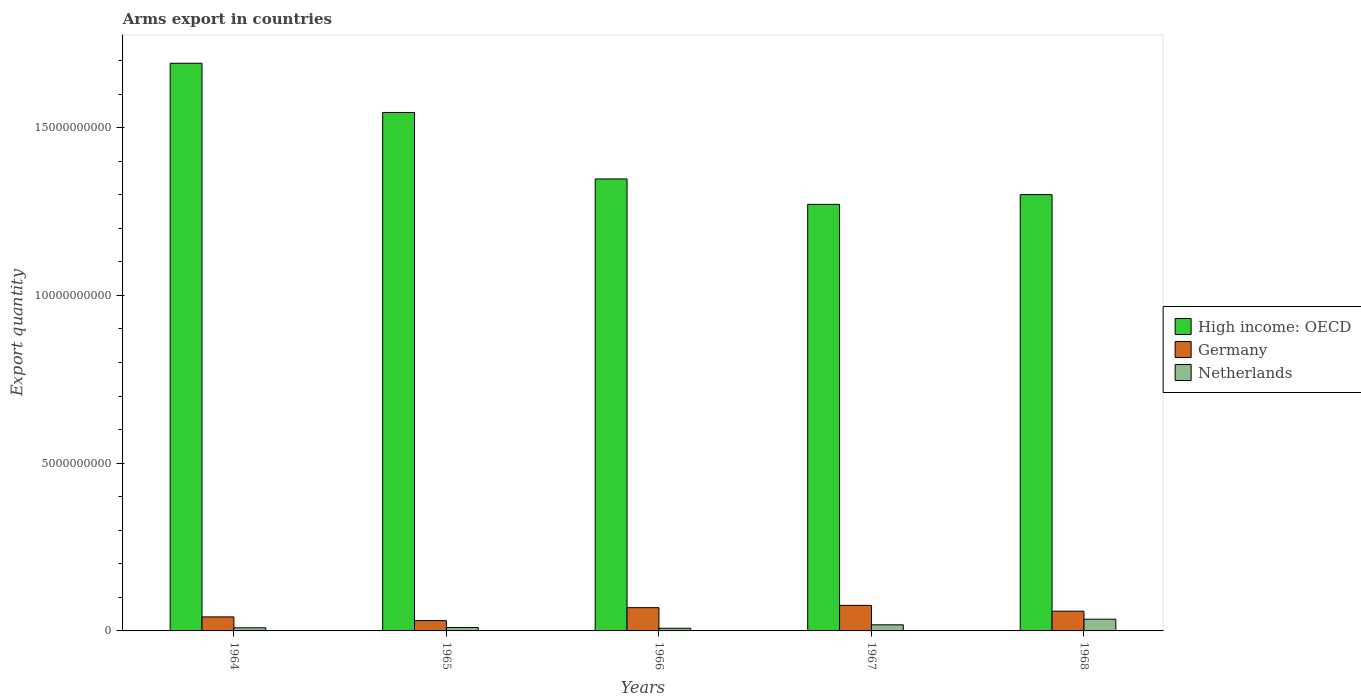What is the label of the 1st group of bars from the left?
Your response must be concise. 1964. What is the total arms export in Netherlands in 1968?
Offer a terse response. 3.50e+08. Across all years, what is the maximum total arms export in Netherlands?
Your answer should be very brief. 3.50e+08. Across all years, what is the minimum total arms export in Netherlands?
Your answer should be very brief. 7.90e+07. In which year was the total arms export in Germany maximum?
Your response must be concise. 1967. In which year was the total arms export in Netherlands minimum?
Offer a terse response. 1966. What is the total total arms export in High income: OECD in the graph?
Provide a short and direct response. 7.16e+1. What is the difference between the total arms export in High income: OECD in 1966 and that in 1968?
Give a very brief answer. 4.67e+08. What is the difference between the total arms export in Netherlands in 1965 and the total arms export in Germany in 1966?
Offer a terse response. -5.93e+08. What is the average total arms export in Netherlands per year?
Your response must be concise. 1.61e+08. In the year 1967, what is the difference between the total arms export in Netherlands and total arms export in Germany?
Your answer should be very brief. -5.79e+08. In how many years, is the total arms export in Netherlands greater than 10000000000?
Give a very brief answer. 0. What is the ratio of the total arms export in High income: OECD in 1965 to that in 1967?
Offer a terse response. 1.22. What is the difference between the highest and the second highest total arms export in Germany?
Offer a very short reply. 6.80e+07. What is the difference between the highest and the lowest total arms export in High income: OECD?
Provide a short and direct response. 4.20e+09. What does the 1st bar from the left in 1965 represents?
Give a very brief answer. High income: OECD. How many bars are there?
Offer a terse response. 15. How many years are there in the graph?
Your answer should be very brief. 5. What is the difference between two consecutive major ticks on the Y-axis?
Provide a succinct answer. 5.00e+09. How many legend labels are there?
Provide a short and direct response. 3. What is the title of the graph?
Give a very brief answer. Arms export in countries. What is the label or title of the Y-axis?
Provide a short and direct response. Export quantity. What is the Export quantity in High income: OECD in 1964?
Keep it short and to the point. 1.69e+1. What is the Export quantity of Germany in 1964?
Keep it short and to the point. 4.18e+08. What is the Export quantity in Netherlands in 1964?
Your response must be concise. 9.30e+07. What is the Export quantity of High income: OECD in 1965?
Give a very brief answer. 1.55e+1. What is the Export quantity of Germany in 1965?
Offer a terse response. 3.07e+08. What is the Export quantity in High income: OECD in 1966?
Ensure brevity in your answer.  1.35e+1. What is the Export quantity of Germany in 1966?
Ensure brevity in your answer.  6.93e+08. What is the Export quantity of Netherlands in 1966?
Offer a very short reply. 7.90e+07. What is the Export quantity in High income: OECD in 1967?
Give a very brief answer. 1.27e+1. What is the Export quantity of Germany in 1967?
Offer a very short reply. 7.61e+08. What is the Export quantity in Netherlands in 1967?
Offer a very short reply. 1.82e+08. What is the Export quantity in High income: OECD in 1968?
Keep it short and to the point. 1.30e+1. What is the Export quantity of Germany in 1968?
Provide a short and direct response. 5.88e+08. What is the Export quantity of Netherlands in 1968?
Make the answer very short. 3.50e+08. Across all years, what is the maximum Export quantity in High income: OECD?
Your answer should be compact. 1.69e+1. Across all years, what is the maximum Export quantity in Germany?
Give a very brief answer. 7.61e+08. Across all years, what is the maximum Export quantity of Netherlands?
Offer a very short reply. 3.50e+08. Across all years, what is the minimum Export quantity of High income: OECD?
Keep it short and to the point. 1.27e+1. Across all years, what is the minimum Export quantity of Germany?
Make the answer very short. 3.07e+08. Across all years, what is the minimum Export quantity of Netherlands?
Provide a short and direct response. 7.90e+07. What is the total Export quantity of High income: OECD in the graph?
Provide a short and direct response. 7.16e+1. What is the total Export quantity of Germany in the graph?
Keep it short and to the point. 2.77e+09. What is the total Export quantity of Netherlands in the graph?
Your answer should be compact. 8.04e+08. What is the difference between the Export quantity of High income: OECD in 1964 and that in 1965?
Your answer should be very brief. 1.47e+09. What is the difference between the Export quantity of Germany in 1964 and that in 1965?
Ensure brevity in your answer.  1.11e+08. What is the difference between the Export quantity of Netherlands in 1964 and that in 1965?
Ensure brevity in your answer.  -7.00e+06. What is the difference between the Export quantity of High income: OECD in 1964 and that in 1966?
Keep it short and to the point. 3.45e+09. What is the difference between the Export quantity in Germany in 1964 and that in 1966?
Keep it short and to the point. -2.75e+08. What is the difference between the Export quantity in Netherlands in 1964 and that in 1966?
Give a very brief answer. 1.40e+07. What is the difference between the Export quantity of High income: OECD in 1964 and that in 1967?
Your answer should be very brief. 4.20e+09. What is the difference between the Export quantity in Germany in 1964 and that in 1967?
Make the answer very short. -3.43e+08. What is the difference between the Export quantity of Netherlands in 1964 and that in 1967?
Ensure brevity in your answer.  -8.90e+07. What is the difference between the Export quantity in High income: OECD in 1964 and that in 1968?
Give a very brief answer. 3.92e+09. What is the difference between the Export quantity in Germany in 1964 and that in 1968?
Your response must be concise. -1.70e+08. What is the difference between the Export quantity of Netherlands in 1964 and that in 1968?
Your answer should be very brief. -2.57e+08. What is the difference between the Export quantity of High income: OECD in 1965 and that in 1966?
Make the answer very short. 1.98e+09. What is the difference between the Export quantity of Germany in 1965 and that in 1966?
Provide a succinct answer. -3.86e+08. What is the difference between the Export quantity of Netherlands in 1965 and that in 1966?
Your answer should be very brief. 2.10e+07. What is the difference between the Export quantity in High income: OECD in 1965 and that in 1967?
Give a very brief answer. 2.74e+09. What is the difference between the Export quantity of Germany in 1965 and that in 1967?
Keep it short and to the point. -4.54e+08. What is the difference between the Export quantity of Netherlands in 1965 and that in 1967?
Your response must be concise. -8.20e+07. What is the difference between the Export quantity in High income: OECD in 1965 and that in 1968?
Your answer should be compact. 2.45e+09. What is the difference between the Export quantity of Germany in 1965 and that in 1968?
Make the answer very short. -2.81e+08. What is the difference between the Export quantity of Netherlands in 1965 and that in 1968?
Provide a succinct answer. -2.50e+08. What is the difference between the Export quantity in High income: OECD in 1966 and that in 1967?
Offer a terse response. 7.57e+08. What is the difference between the Export quantity of Germany in 1966 and that in 1967?
Provide a short and direct response. -6.80e+07. What is the difference between the Export quantity in Netherlands in 1966 and that in 1967?
Make the answer very short. -1.03e+08. What is the difference between the Export quantity in High income: OECD in 1966 and that in 1968?
Offer a terse response. 4.67e+08. What is the difference between the Export quantity in Germany in 1966 and that in 1968?
Provide a short and direct response. 1.05e+08. What is the difference between the Export quantity in Netherlands in 1966 and that in 1968?
Keep it short and to the point. -2.71e+08. What is the difference between the Export quantity in High income: OECD in 1967 and that in 1968?
Your answer should be very brief. -2.90e+08. What is the difference between the Export quantity in Germany in 1967 and that in 1968?
Provide a short and direct response. 1.73e+08. What is the difference between the Export quantity in Netherlands in 1967 and that in 1968?
Make the answer very short. -1.68e+08. What is the difference between the Export quantity in High income: OECD in 1964 and the Export quantity in Germany in 1965?
Offer a very short reply. 1.66e+1. What is the difference between the Export quantity in High income: OECD in 1964 and the Export quantity in Netherlands in 1965?
Your answer should be very brief. 1.68e+1. What is the difference between the Export quantity in Germany in 1964 and the Export quantity in Netherlands in 1965?
Offer a very short reply. 3.18e+08. What is the difference between the Export quantity in High income: OECD in 1964 and the Export quantity in Germany in 1966?
Your answer should be very brief. 1.62e+1. What is the difference between the Export quantity in High income: OECD in 1964 and the Export quantity in Netherlands in 1966?
Provide a short and direct response. 1.68e+1. What is the difference between the Export quantity of Germany in 1964 and the Export quantity of Netherlands in 1966?
Ensure brevity in your answer.  3.39e+08. What is the difference between the Export quantity of High income: OECD in 1964 and the Export quantity of Germany in 1967?
Your answer should be compact. 1.62e+1. What is the difference between the Export quantity of High income: OECD in 1964 and the Export quantity of Netherlands in 1967?
Your answer should be very brief. 1.67e+1. What is the difference between the Export quantity in Germany in 1964 and the Export quantity in Netherlands in 1967?
Your answer should be very brief. 2.36e+08. What is the difference between the Export quantity in High income: OECD in 1964 and the Export quantity in Germany in 1968?
Make the answer very short. 1.63e+1. What is the difference between the Export quantity of High income: OECD in 1964 and the Export quantity of Netherlands in 1968?
Make the answer very short. 1.66e+1. What is the difference between the Export quantity of Germany in 1964 and the Export quantity of Netherlands in 1968?
Ensure brevity in your answer.  6.80e+07. What is the difference between the Export quantity in High income: OECD in 1965 and the Export quantity in Germany in 1966?
Your answer should be very brief. 1.48e+1. What is the difference between the Export quantity of High income: OECD in 1965 and the Export quantity of Netherlands in 1966?
Make the answer very short. 1.54e+1. What is the difference between the Export quantity in Germany in 1965 and the Export quantity in Netherlands in 1966?
Your response must be concise. 2.28e+08. What is the difference between the Export quantity of High income: OECD in 1965 and the Export quantity of Germany in 1967?
Provide a short and direct response. 1.47e+1. What is the difference between the Export quantity in High income: OECD in 1965 and the Export quantity in Netherlands in 1967?
Give a very brief answer. 1.53e+1. What is the difference between the Export quantity of Germany in 1965 and the Export quantity of Netherlands in 1967?
Ensure brevity in your answer.  1.25e+08. What is the difference between the Export quantity of High income: OECD in 1965 and the Export quantity of Germany in 1968?
Offer a terse response. 1.49e+1. What is the difference between the Export quantity of High income: OECD in 1965 and the Export quantity of Netherlands in 1968?
Your answer should be very brief. 1.51e+1. What is the difference between the Export quantity in Germany in 1965 and the Export quantity in Netherlands in 1968?
Your answer should be very brief. -4.30e+07. What is the difference between the Export quantity of High income: OECD in 1966 and the Export quantity of Germany in 1967?
Keep it short and to the point. 1.27e+1. What is the difference between the Export quantity of High income: OECD in 1966 and the Export quantity of Netherlands in 1967?
Your response must be concise. 1.33e+1. What is the difference between the Export quantity of Germany in 1966 and the Export quantity of Netherlands in 1967?
Your answer should be very brief. 5.11e+08. What is the difference between the Export quantity in High income: OECD in 1966 and the Export quantity in Germany in 1968?
Keep it short and to the point. 1.29e+1. What is the difference between the Export quantity in High income: OECD in 1966 and the Export quantity in Netherlands in 1968?
Provide a short and direct response. 1.31e+1. What is the difference between the Export quantity in Germany in 1966 and the Export quantity in Netherlands in 1968?
Provide a succinct answer. 3.43e+08. What is the difference between the Export quantity in High income: OECD in 1967 and the Export quantity in Germany in 1968?
Offer a very short reply. 1.21e+1. What is the difference between the Export quantity of High income: OECD in 1967 and the Export quantity of Netherlands in 1968?
Provide a succinct answer. 1.24e+1. What is the difference between the Export quantity of Germany in 1967 and the Export quantity of Netherlands in 1968?
Provide a short and direct response. 4.11e+08. What is the average Export quantity of High income: OECD per year?
Your answer should be compact. 1.43e+1. What is the average Export quantity of Germany per year?
Make the answer very short. 5.53e+08. What is the average Export quantity of Netherlands per year?
Provide a succinct answer. 1.61e+08. In the year 1964, what is the difference between the Export quantity of High income: OECD and Export quantity of Germany?
Your answer should be compact. 1.65e+1. In the year 1964, what is the difference between the Export quantity in High income: OECD and Export quantity in Netherlands?
Offer a terse response. 1.68e+1. In the year 1964, what is the difference between the Export quantity of Germany and Export quantity of Netherlands?
Give a very brief answer. 3.25e+08. In the year 1965, what is the difference between the Export quantity of High income: OECD and Export quantity of Germany?
Your answer should be very brief. 1.51e+1. In the year 1965, what is the difference between the Export quantity in High income: OECD and Export quantity in Netherlands?
Ensure brevity in your answer.  1.54e+1. In the year 1965, what is the difference between the Export quantity of Germany and Export quantity of Netherlands?
Provide a succinct answer. 2.07e+08. In the year 1966, what is the difference between the Export quantity of High income: OECD and Export quantity of Germany?
Provide a short and direct response. 1.28e+1. In the year 1966, what is the difference between the Export quantity in High income: OECD and Export quantity in Netherlands?
Your response must be concise. 1.34e+1. In the year 1966, what is the difference between the Export quantity in Germany and Export quantity in Netherlands?
Your response must be concise. 6.14e+08. In the year 1967, what is the difference between the Export quantity in High income: OECD and Export quantity in Germany?
Offer a very short reply. 1.20e+1. In the year 1967, what is the difference between the Export quantity in High income: OECD and Export quantity in Netherlands?
Offer a very short reply. 1.25e+1. In the year 1967, what is the difference between the Export quantity in Germany and Export quantity in Netherlands?
Provide a succinct answer. 5.79e+08. In the year 1968, what is the difference between the Export quantity in High income: OECD and Export quantity in Germany?
Ensure brevity in your answer.  1.24e+1. In the year 1968, what is the difference between the Export quantity of High income: OECD and Export quantity of Netherlands?
Make the answer very short. 1.27e+1. In the year 1968, what is the difference between the Export quantity in Germany and Export quantity in Netherlands?
Make the answer very short. 2.38e+08. What is the ratio of the Export quantity of High income: OECD in 1964 to that in 1965?
Offer a very short reply. 1.09. What is the ratio of the Export quantity of Germany in 1964 to that in 1965?
Give a very brief answer. 1.36. What is the ratio of the Export quantity in Netherlands in 1964 to that in 1965?
Provide a short and direct response. 0.93. What is the ratio of the Export quantity in High income: OECD in 1964 to that in 1966?
Your answer should be compact. 1.26. What is the ratio of the Export quantity in Germany in 1964 to that in 1966?
Offer a very short reply. 0.6. What is the ratio of the Export quantity of Netherlands in 1964 to that in 1966?
Give a very brief answer. 1.18. What is the ratio of the Export quantity in High income: OECD in 1964 to that in 1967?
Offer a terse response. 1.33. What is the ratio of the Export quantity in Germany in 1964 to that in 1967?
Your answer should be very brief. 0.55. What is the ratio of the Export quantity in Netherlands in 1964 to that in 1967?
Ensure brevity in your answer.  0.51. What is the ratio of the Export quantity in High income: OECD in 1964 to that in 1968?
Make the answer very short. 1.3. What is the ratio of the Export quantity of Germany in 1964 to that in 1968?
Your answer should be very brief. 0.71. What is the ratio of the Export quantity in Netherlands in 1964 to that in 1968?
Give a very brief answer. 0.27. What is the ratio of the Export quantity in High income: OECD in 1965 to that in 1966?
Offer a very short reply. 1.15. What is the ratio of the Export quantity in Germany in 1965 to that in 1966?
Your answer should be very brief. 0.44. What is the ratio of the Export quantity in Netherlands in 1965 to that in 1966?
Your answer should be compact. 1.27. What is the ratio of the Export quantity of High income: OECD in 1965 to that in 1967?
Your answer should be very brief. 1.22. What is the ratio of the Export quantity in Germany in 1965 to that in 1967?
Your answer should be compact. 0.4. What is the ratio of the Export quantity in Netherlands in 1965 to that in 1967?
Make the answer very short. 0.55. What is the ratio of the Export quantity of High income: OECD in 1965 to that in 1968?
Give a very brief answer. 1.19. What is the ratio of the Export quantity of Germany in 1965 to that in 1968?
Your answer should be very brief. 0.52. What is the ratio of the Export quantity of Netherlands in 1965 to that in 1968?
Offer a very short reply. 0.29. What is the ratio of the Export quantity of High income: OECD in 1966 to that in 1967?
Ensure brevity in your answer.  1.06. What is the ratio of the Export quantity in Germany in 1966 to that in 1967?
Your response must be concise. 0.91. What is the ratio of the Export quantity of Netherlands in 1966 to that in 1967?
Keep it short and to the point. 0.43. What is the ratio of the Export quantity of High income: OECD in 1966 to that in 1968?
Your answer should be compact. 1.04. What is the ratio of the Export quantity of Germany in 1966 to that in 1968?
Give a very brief answer. 1.18. What is the ratio of the Export quantity in Netherlands in 1966 to that in 1968?
Provide a short and direct response. 0.23. What is the ratio of the Export quantity in High income: OECD in 1967 to that in 1968?
Keep it short and to the point. 0.98. What is the ratio of the Export quantity in Germany in 1967 to that in 1968?
Your answer should be compact. 1.29. What is the ratio of the Export quantity in Netherlands in 1967 to that in 1968?
Your answer should be compact. 0.52. What is the difference between the highest and the second highest Export quantity of High income: OECD?
Offer a very short reply. 1.47e+09. What is the difference between the highest and the second highest Export quantity of Germany?
Provide a succinct answer. 6.80e+07. What is the difference between the highest and the second highest Export quantity in Netherlands?
Give a very brief answer. 1.68e+08. What is the difference between the highest and the lowest Export quantity in High income: OECD?
Ensure brevity in your answer.  4.20e+09. What is the difference between the highest and the lowest Export quantity in Germany?
Provide a succinct answer. 4.54e+08. What is the difference between the highest and the lowest Export quantity of Netherlands?
Ensure brevity in your answer.  2.71e+08. 